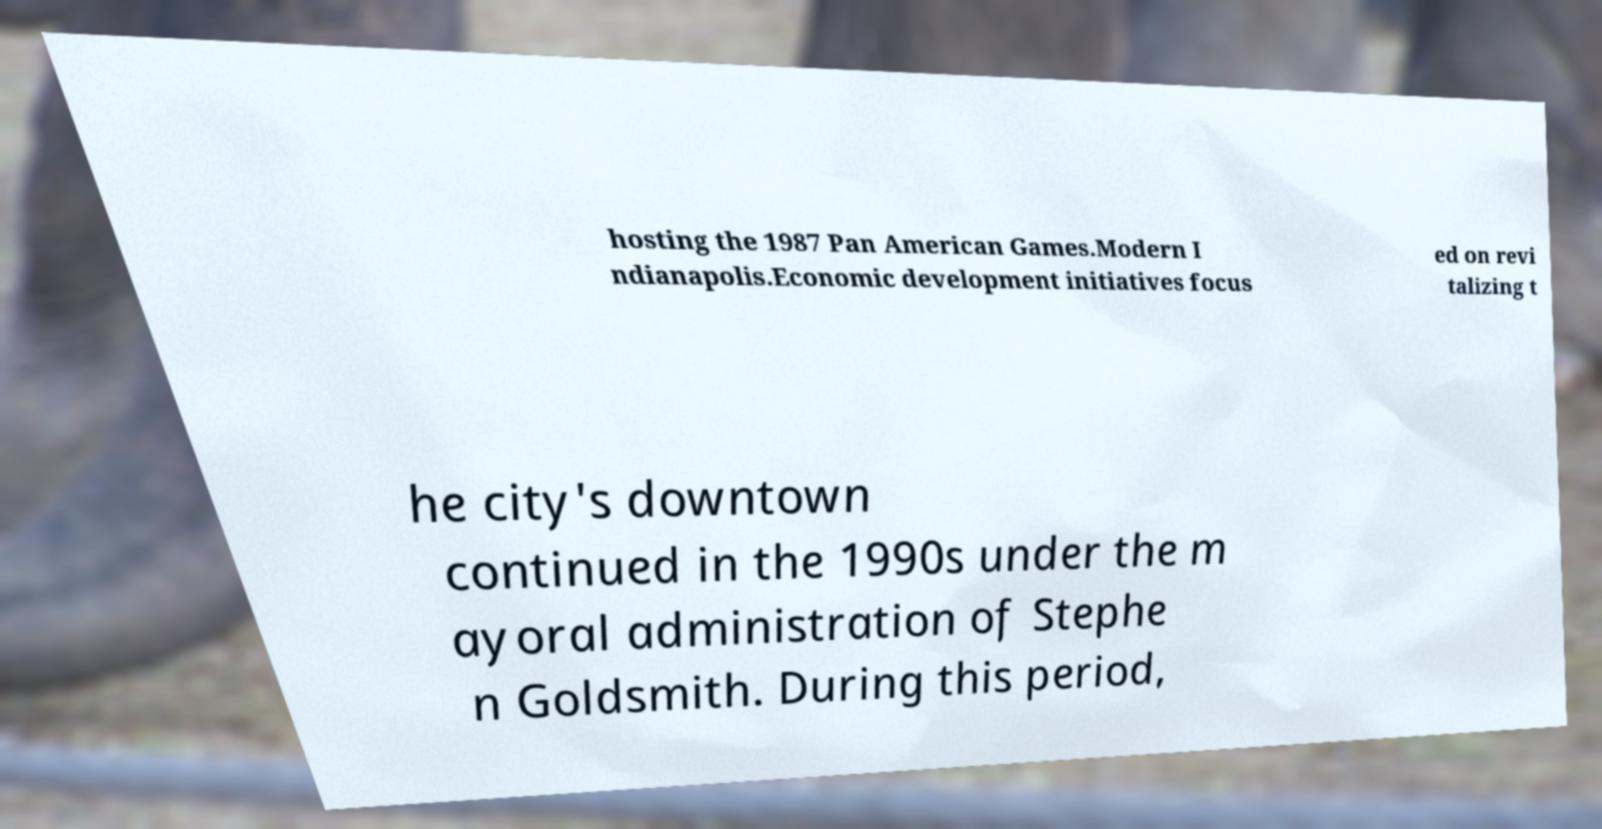There's text embedded in this image that I need extracted. Can you transcribe it verbatim? hosting the 1987 Pan American Games.Modern I ndianapolis.Economic development initiatives focus ed on revi talizing t he city's downtown continued in the 1990s under the m ayoral administration of Stephe n Goldsmith. During this period, 